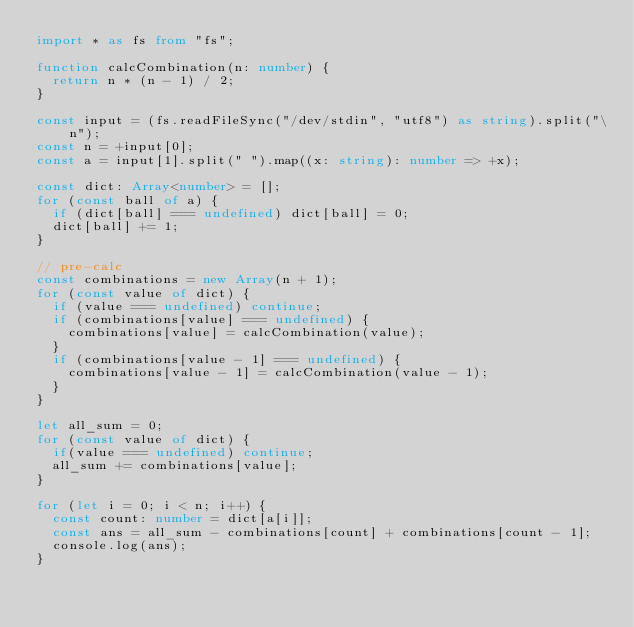Convert code to text. <code><loc_0><loc_0><loc_500><loc_500><_TypeScript_>import * as fs from "fs";

function calcCombination(n: number) {
	return n * (n - 1) / 2;
}

const input = (fs.readFileSync("/dev/stdin", "utf8") as string).split("\n");
const n = +input[0];
const a = input[1].split(" ").map((x: string): number => +x);

const dict: Array<number> = [];
for (const ball of a) {
	if (dict[ball] === undefined) dict[ball] = 0;
	dict[ball] += 1;
}

// pre-calc
const combinations = new Array(n + 1);
for (const value of dict) {
	if (value === undefined) continue;
	if (combinations[value] === undefined) {
		combinations[value] = calcCombination(value);
	}
	if (combinations[value - 1] === undefined) {
		combinations[value - 1] = calcCombination(value - 1);
	}
}

let all_sum = 0;
for (const value of dict) {
	if(value === undefined) continue;
	all_sum += combinations[value];
}

for (let i = 0; i < n; i++) {
	const count: number = dict[a[i]];
	const ans = all_sum - combinations[count] + combinations[count - 1];
	console.log(ans);
}
</code> 